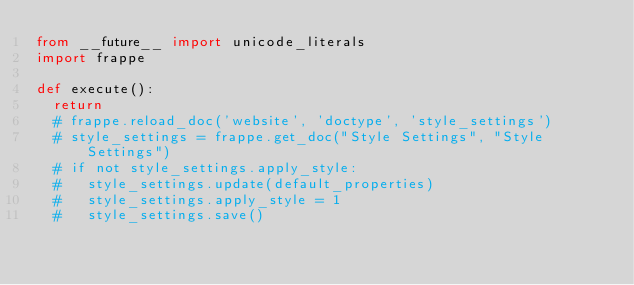Convert code to text. <code><loc_0><loc_0><loc_500><loc_500><_Python_>from __future__ import unicode_literals
import frappe

def execute():
	return
	# frappe.reload_doc('website', 'doctype', 'style_settings')
	# style_settings = frappe.get_doc("Style Settings", "Style Settings")
	# if not style_settings.apply_style:
	# 	style_settings.update(default_properties)
	# 	style_settings.apply_style = 1
	# 	style_settings.save()
</code> 